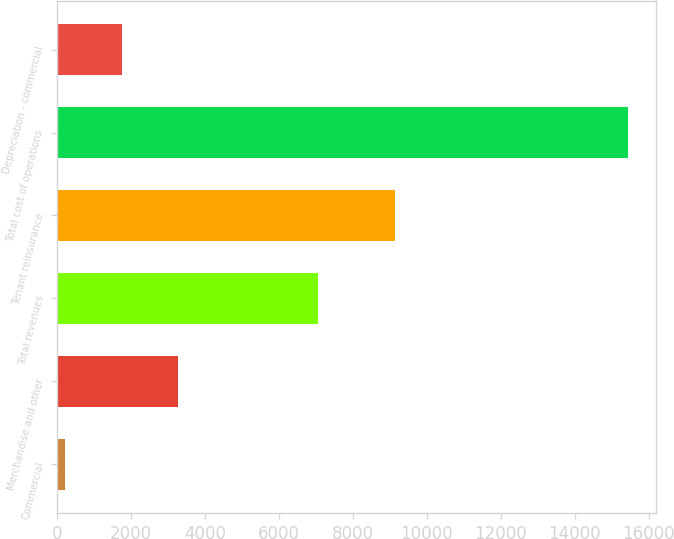Convert chart to OTSL. <chart><loc_0><loc_0><loc_500><loc_500><bar_chart><fcel>Commercial<fcel>Merchandise and other<fcel>Total revenues<fcel>Tenant reinsurance<fcel>Total cost of operations<fcel>Depreciation - commercial<nl><fcel>225<fcel>3266.6<fcel>7060<fcel>9145<fcel>15433<fcel>1745.8<nl></chart> 